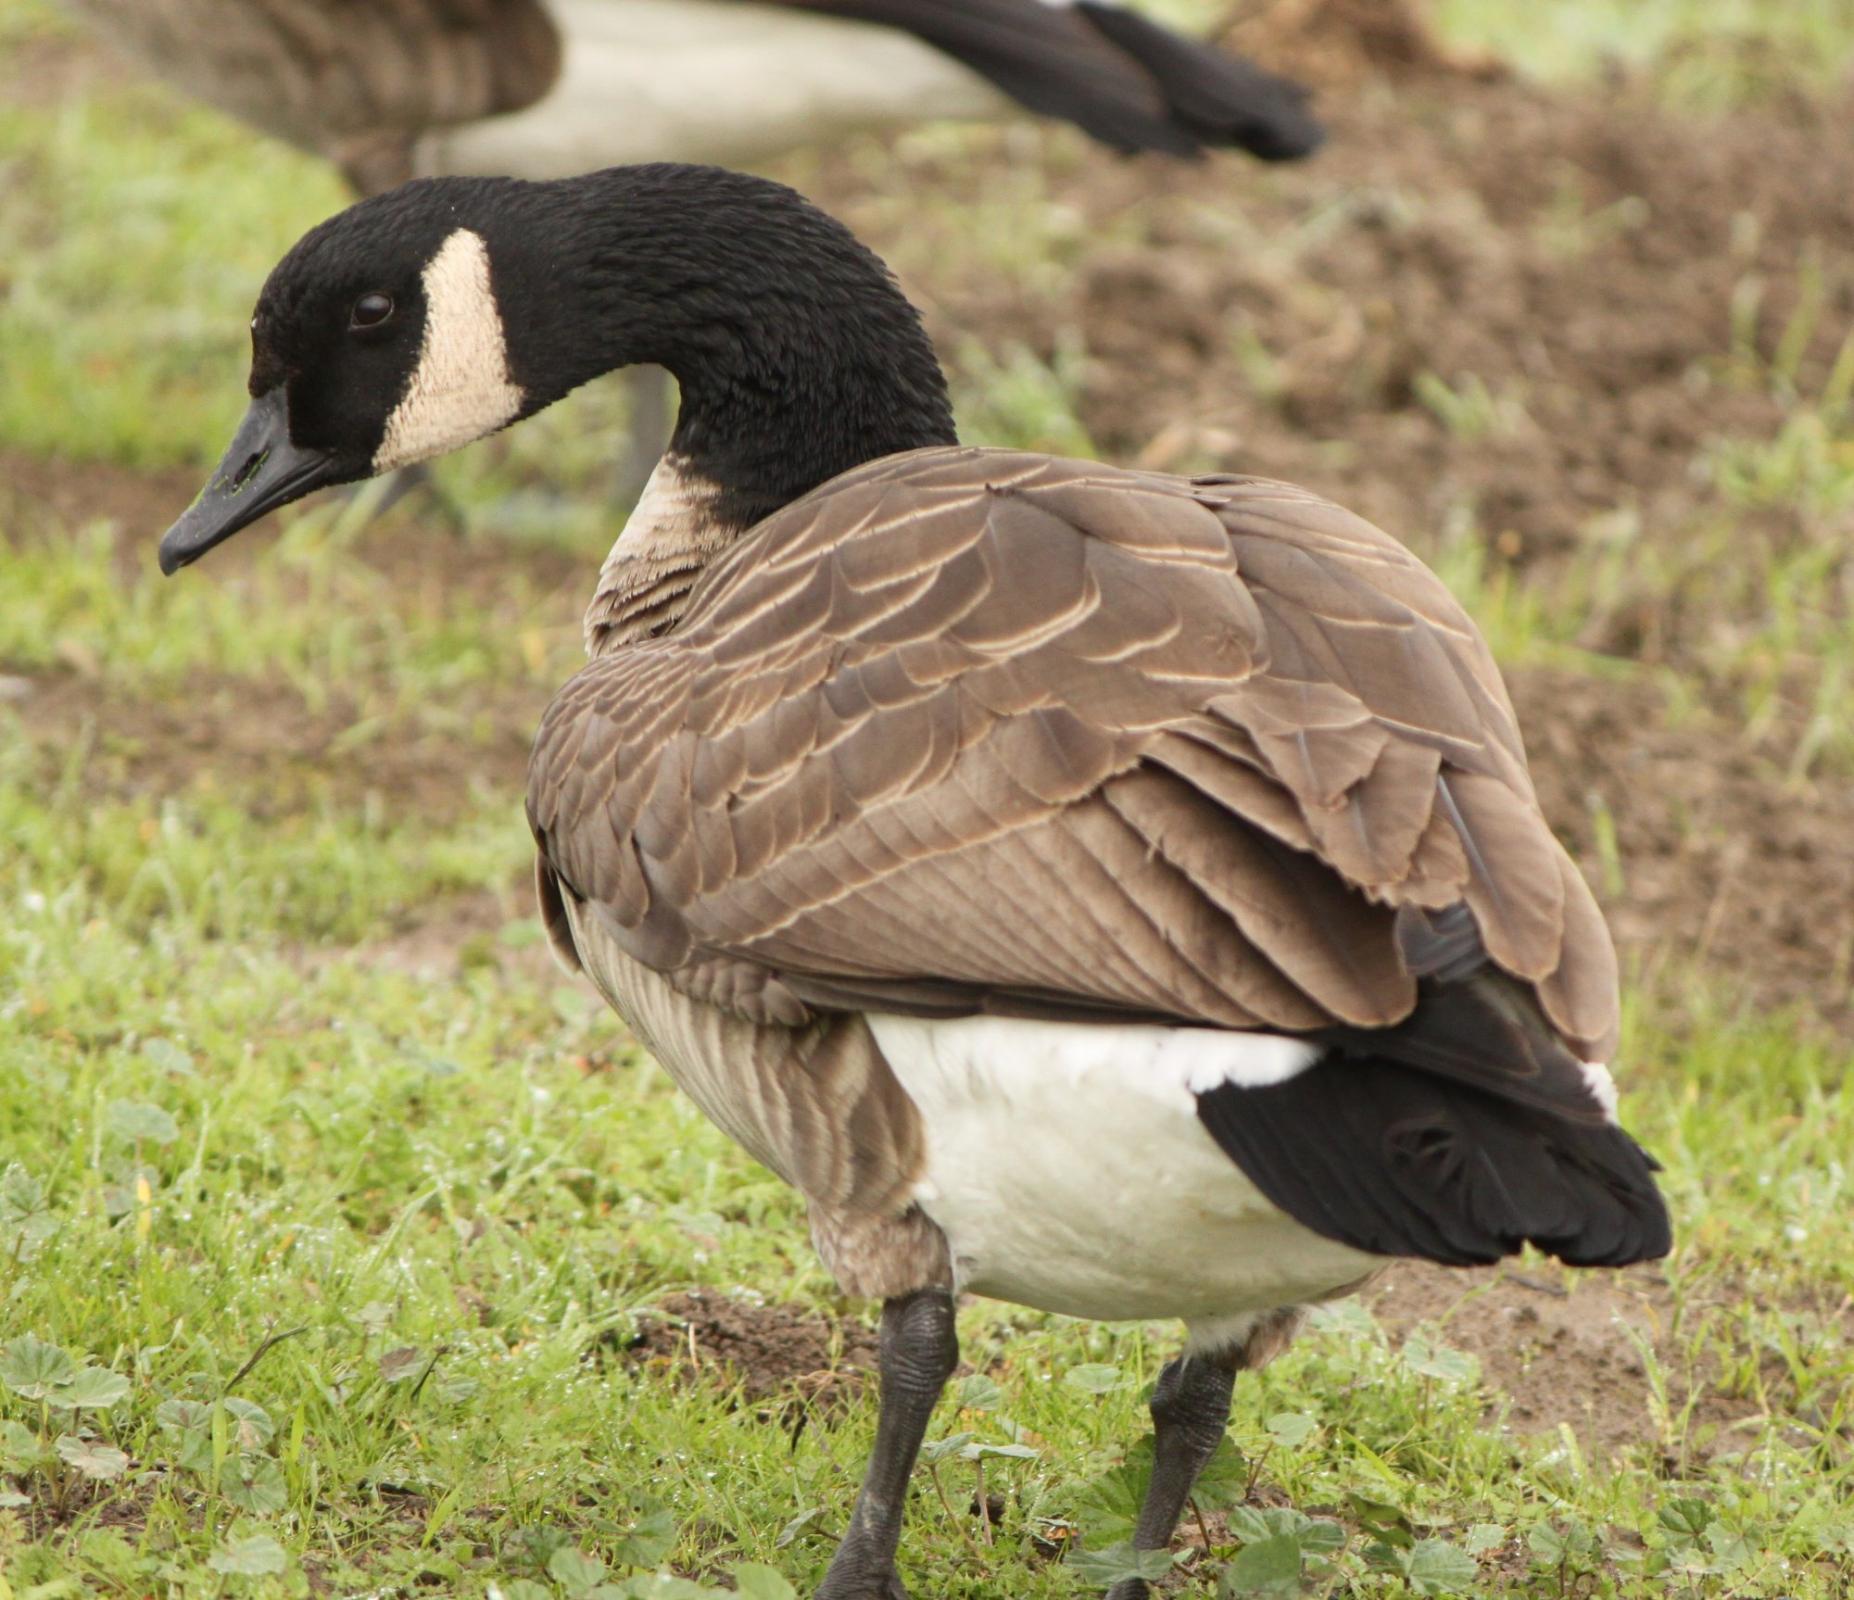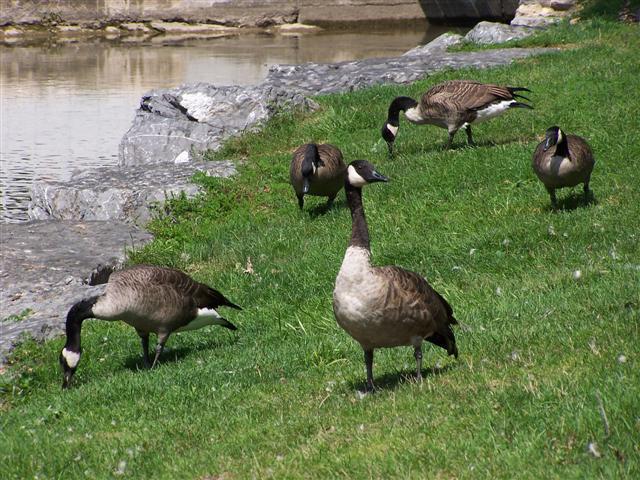The first image is the image on the left, the second image is the image on the right. Examine the images to the left and right. Is the description "A girl with long blonde hair is seated beside birds in one of the images." accurate? Answer yes or no. No. The first image is the image on the left, the second image is the image on the right. Examine the images to the left and right. Is the description "The left image has at least 4 birds facing left." accurate? Answer yes or no. No. 